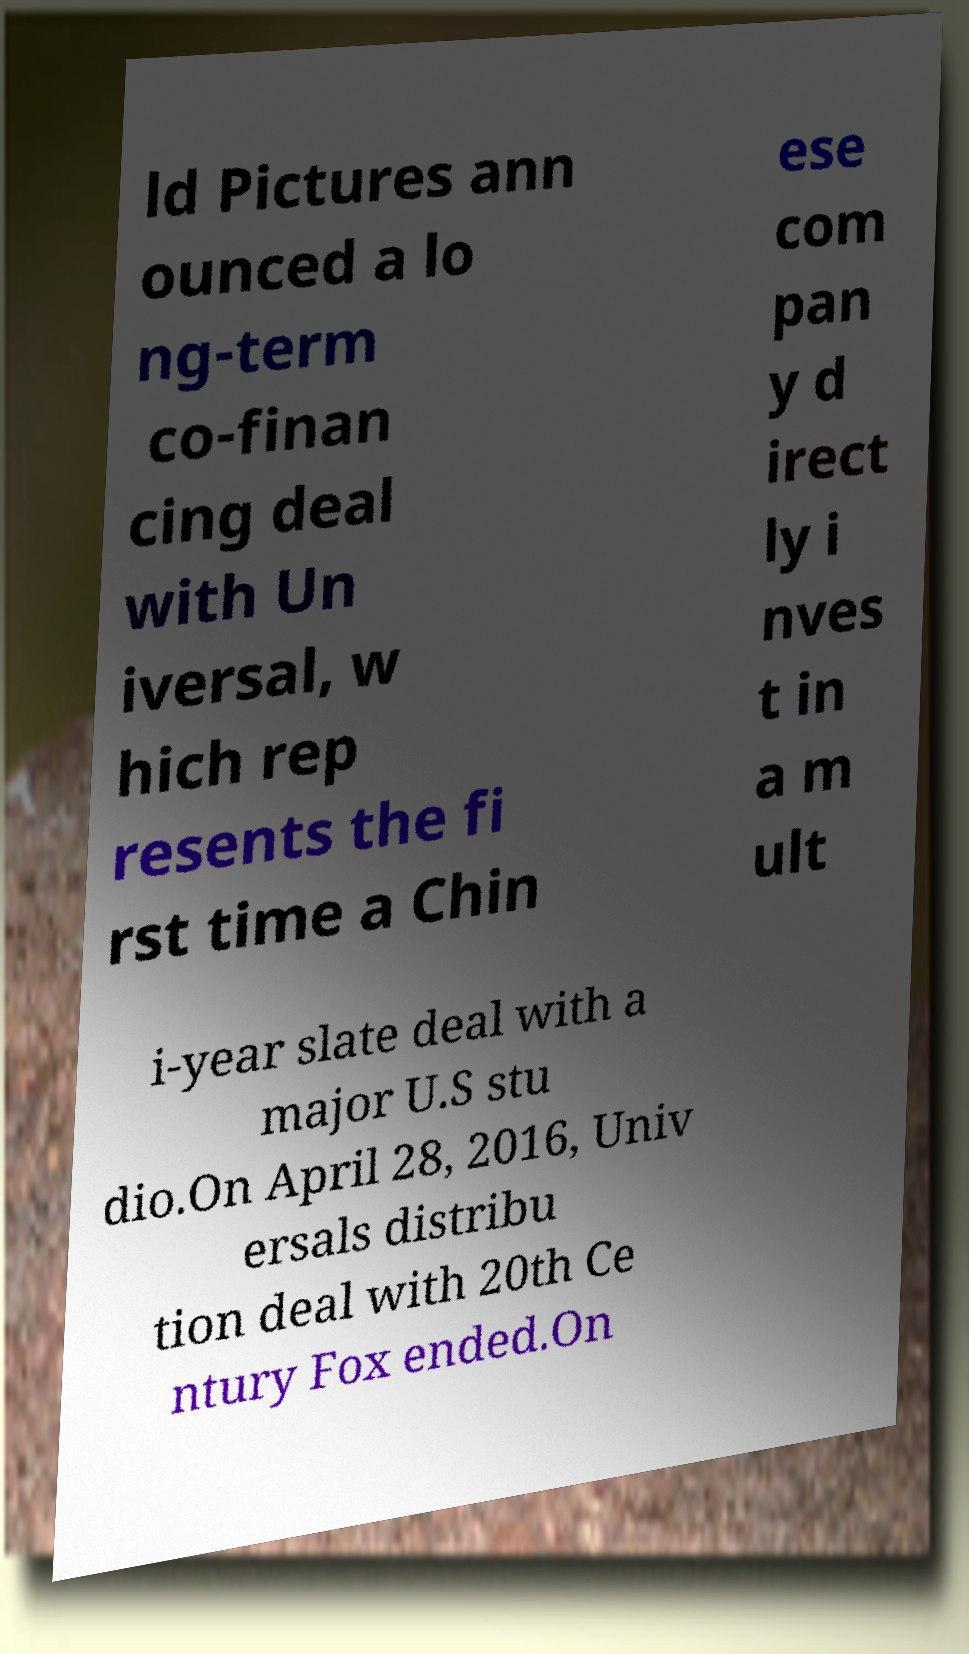Can you read and provide the text displayed in the image?This photo seems to have some interesting text. Can you extract and type it out for me? ld Pictures ann ounced a lo ng-term co-finan cing deal with Un iversal, w hich rep resents the fi rst time a Chin ese com pan y d irect ly i nves t in a m ult i-year slate deal with a major U.S stu dio.On April 28, 2016, Univ ersals distribu tion deal with 20th Ce ntury Fox ended.On 